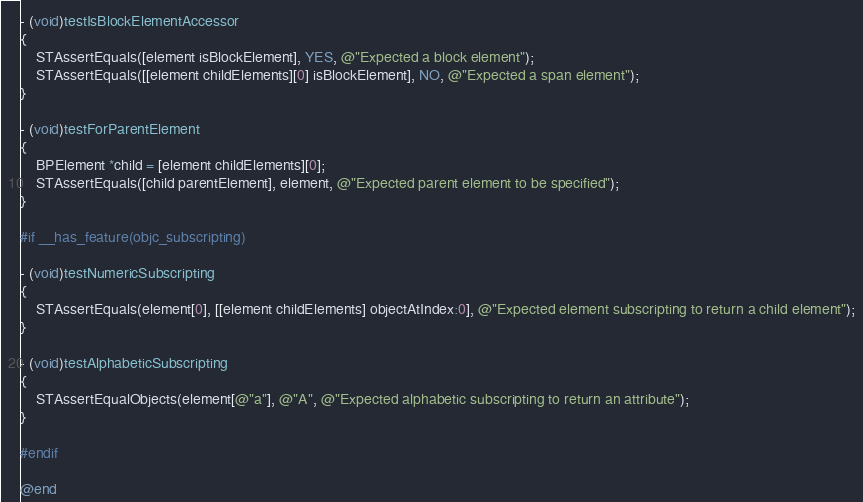<code> <loc_0><loc_0><loc_500><loc_500><_ObjectiveC_>
- (void)testIsBlockElementAccessor
{
    STAssertEquals([element isBlockElement], YES, @"Expected a block element");
    STAssertEquals([[element childElements][0] isBlockElement], NO, @"Expected a span element");
}

- (void)testForParentElement
{
    BPElement *child = [element childElements][0];
    STAssertEquals([child parentElement], element, @"Expected parent element to be specified");
}

#if __has_feature(objc_subscripting)

- (void)testNumericSubscripting
{
    STAssertEquals(element[0], [[element childElements] objectAtIndex:0], @"Expected element subscripting to return a child element");
}

- (void)testAlphabeticSubscripting
{
    STAssertEqualObjects(element[@"a"], @"A", @"Expected alphabetic subscripting to return an attribute");
}

#endif

@end
</code> 